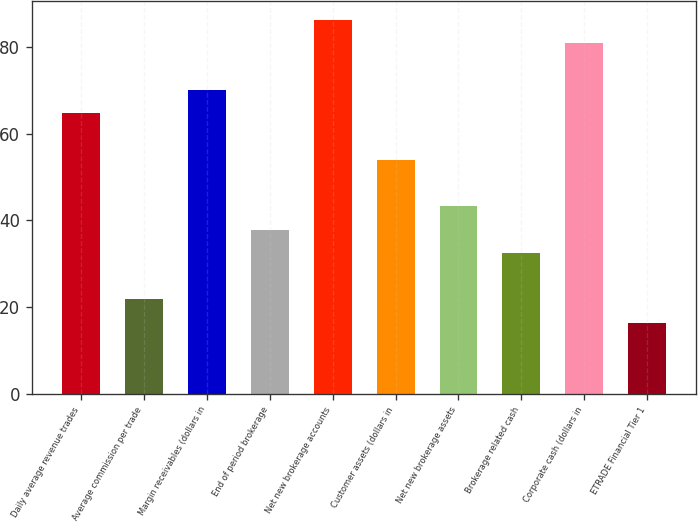<chart> <loc_0><loc_0><loc_500><loc_500><bar_chart><fcel>Daily average revenue trades<fcel>Average commission per trade<fcel>Margin receivables (dollars in<fcel>End of period brokerage<fcel>Net new brokerage accounts<fcel>Customer assets (dollars in<fcel>Net new brokerage assets<fcel>Brokerage related cash<fcel>Corporate cash (dollars in<fcel>ETRADE Financial Tier 1<nl><fcel>64.78<fcel>21.74<fcel>70.16<fcel>37.88<fcel>86.3<fcel>54.02<fcel>43.26<fcel>32.5<fcel>80.92<fcel>16.36<nl></chart> 